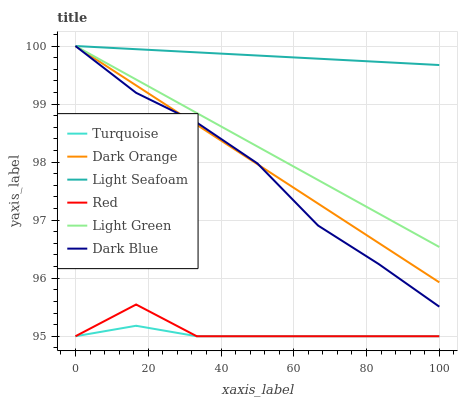Does Dark Blue have the minimum area under the curve?
Answer yes or no. No. Does Dark Blue have the maximum area under the curve?
Answer yes or no. No. Is Turquoise the smoothest?
Answer yes or no. No. Is Turquoise the roughest?
Answer yes or no. No. Does Dark Blue have the lowest value?
Answer yes or no. No. Does Turquoise have the highest value?
Answer yes or no. No. Is Turquoise less than Light Seafoam?
Answer yes or no. Yes. Is Dark Blue greater than Turquoise?
Answer yes or no. Yes. Does Turquoise intersect Light Seafoam?
Answer yes or no. No. 